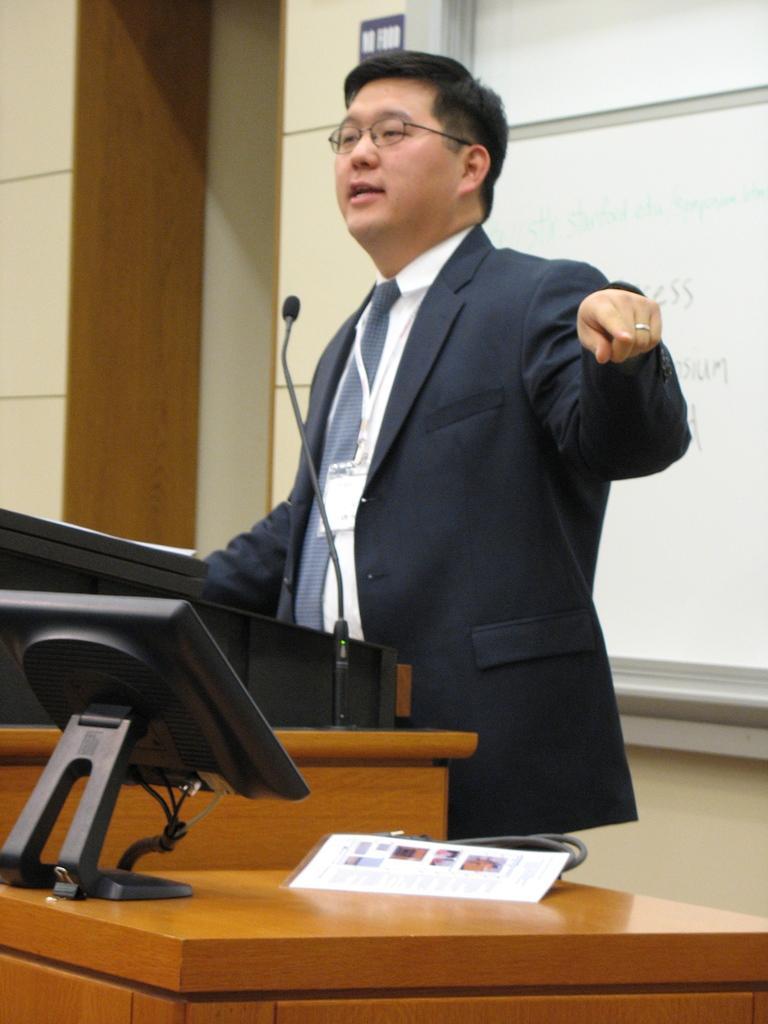Describe this image in one or two sentences. In this picture there is a man standing. There is a podium and a mic. A computer and a wire is seen on the wooden table. A blackboard is visible in the background. 